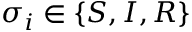<formula> <loc_0><loc_0><loc_500><loc_500>\sigma _ { i } \in \{ S , I , R \}</formula> 